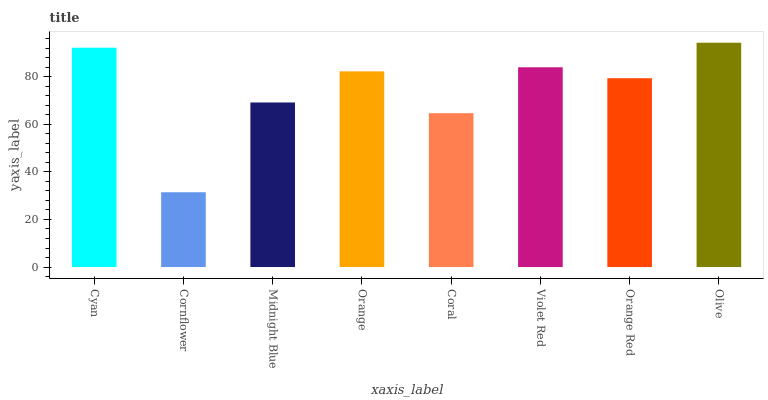Is Cornflower the minimum?
Answer yes or no. Yes. Is Olive the maximum?
Answer yes or no. Yes. Is Midnight Blue the minimum?
Answer yes or no. No. Is Midnight Blue the maximum?
Answer yes or no. No. Is Midnight Blue greater than Cornflower?
Answer yes or no. Yes. Is Cornflower less than Midnight Blue?
Answer yes or no. Yes. Is Cornflower greater than Midnight Blue?
Answer yes or no. No. Is Midnight Blue less than Cornflower?
Answer yes or no. No. Is Orange the high median?
Answer yes or no. Yes. Is Orange Red the low median?
Answer yes or no. Yes. Is Cyan the high median?
Answer yes or no. No. Is Cyan the low median?
Answer yes or no. No. 